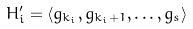Convert formula to latex. <formula><loc_0><loc_0><loc_500><loc_500>H _ { i } ^ { \prime } = \langle g _ { k _ { i } } , g _ { k _ { i } + 1 } , \dots , g _ { s } \rangle</formula> 